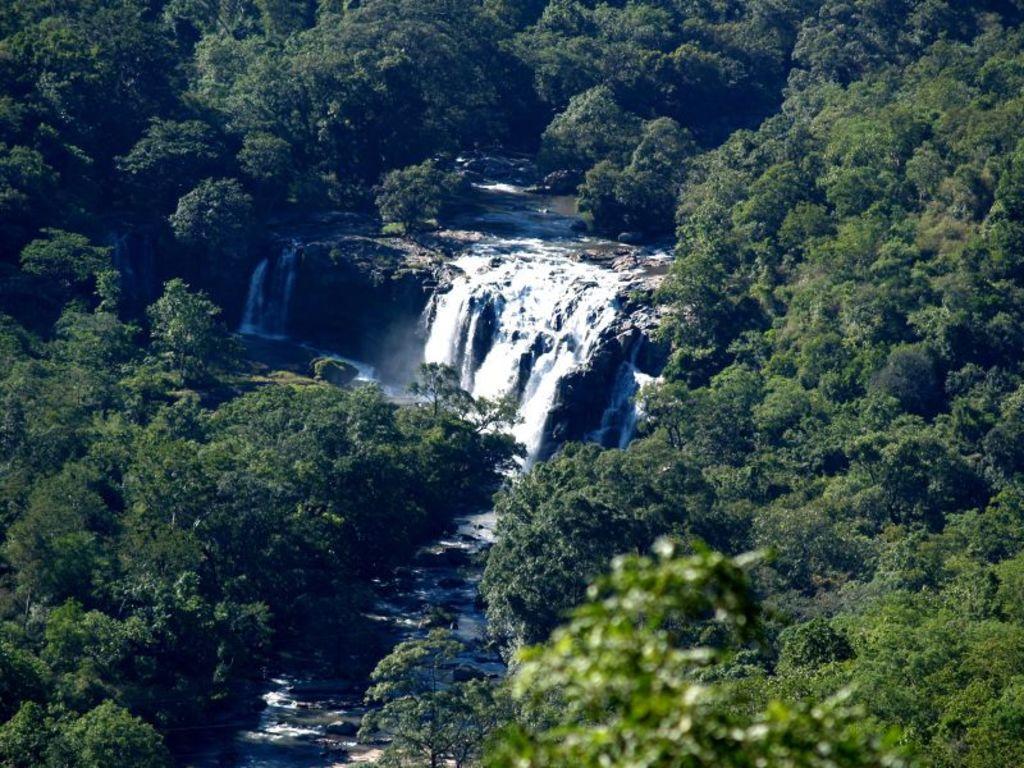In one or two sentences, can you explain what this image depicts? In the center of the image we can see a waterfall. In the background there are trees. 